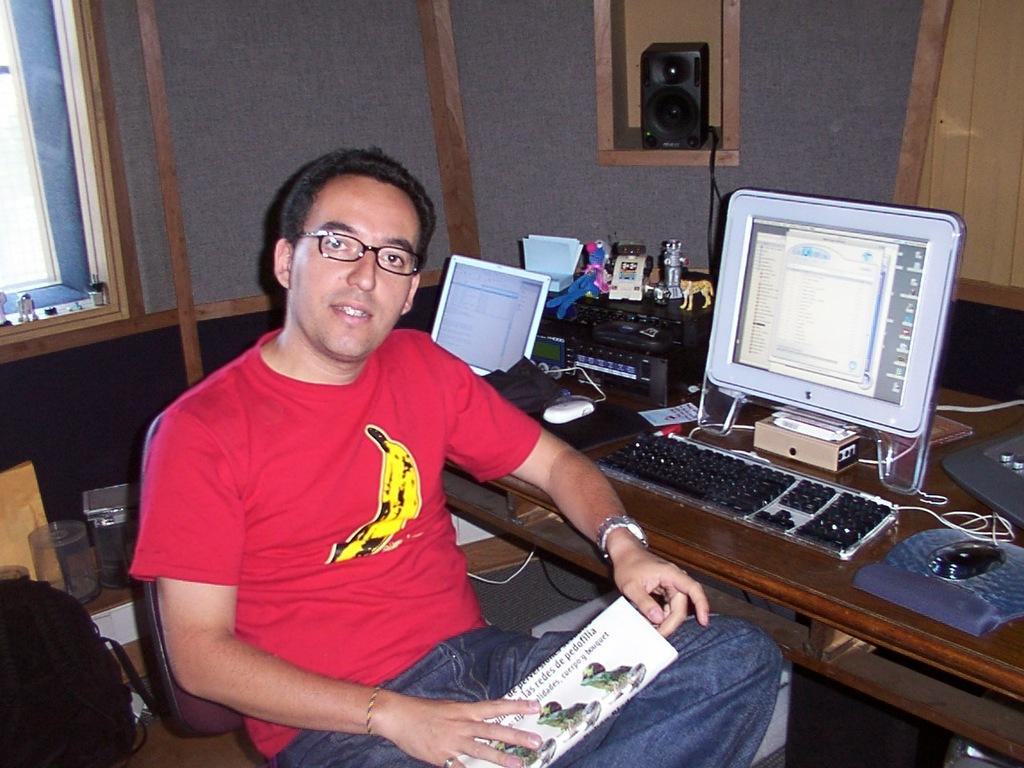What is the person in the image doing? The person is sitting in the image. Where is the person sitting in relation to the table? The person is sitting in front of a table. What is on the table in the image? There is a system and objects on the table. Can you see any arguments happening between the person and the objects on the table? There is no indication of an argument in the image; the person is simply sitting in front of the table with objects and a system present. 